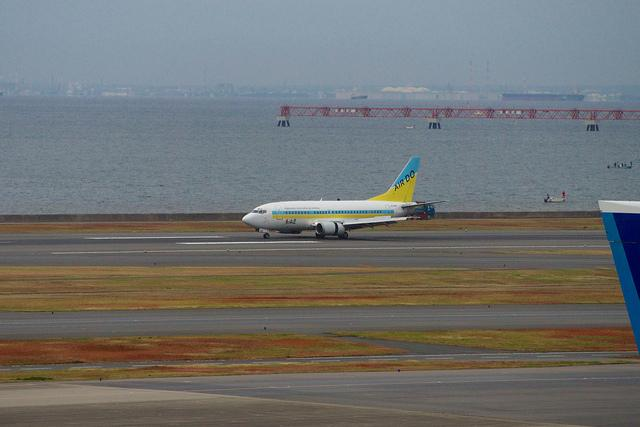The colors of this vehicle resemble which flag? ukraine 